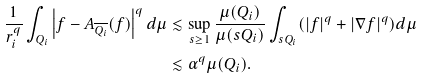Convert formula to latex. <formula><loc_0><loc_0><loc_500><loc_500>\frac { 1 } { r _ { i } ^ { q } } \int _ { Q _ { i } } \left | f - A _ { \overline { Q _ { i } } } ( f ) \right | ^ { q } d \mu & \lesssim \sup _ { s \geq 1 } \frac { \mu ( Q _ { i } ) } { \mu ( s Q _ { i } ) } \int _ { s Q _ { i } } ( | f | ^ { q } + | \nabla f | ^ { q } ) d \mu \\ & \lesssim \alpha ^ { q } \mu ( Q _ { i } ) .</formula> 